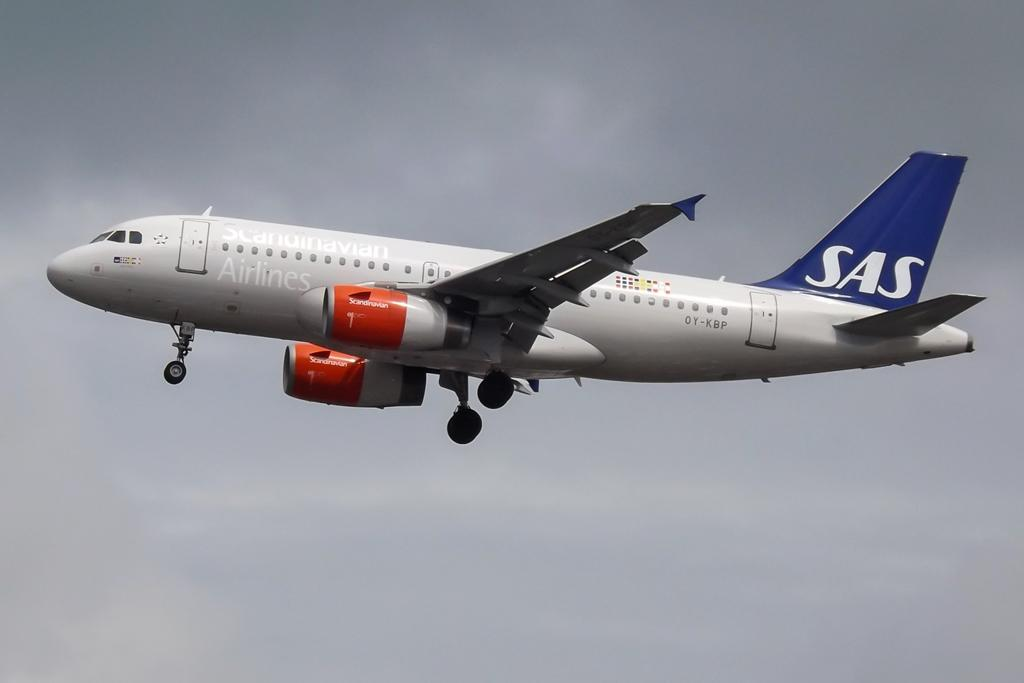<image>
Write a terse but informative summary of the picture. Scandinavia Airlines airplane with SAS on the back. 